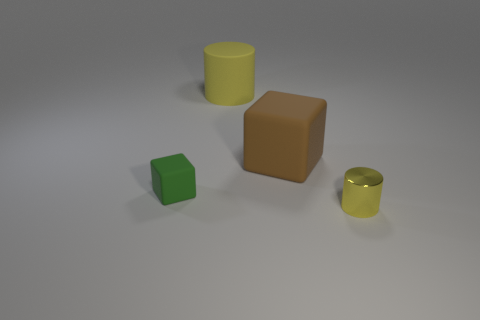What number of other things are the same size as the brown matte cube? Besides the brown matte cube, there is one object, the green matte cube, that appears to be of a similar size. 